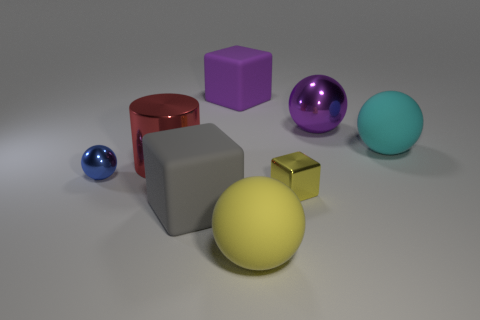Can you describe the different materials and their properties shown in the image? Certainly! The image displays various objects with two prominent types of materials. Some objects have a reflective, glossy finish, indicating a smooth material like polished metal or plastic. This includes the purple ball, the yellow cube, and the larger gray cube. Meanwhile, the red cylinder and the teal sphere seem to possess a matte finish, suggesting a surface that diffuses light, possibly like painted wood or a non-glossy plastic. 